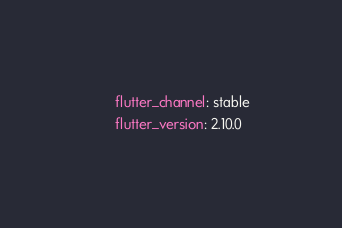Convert code to text. <code><loc_0><loc_0><loc_500><loc_500><_YAML_>      flutter_channel: stable
      flutter_version: 2.10.0
</code> 